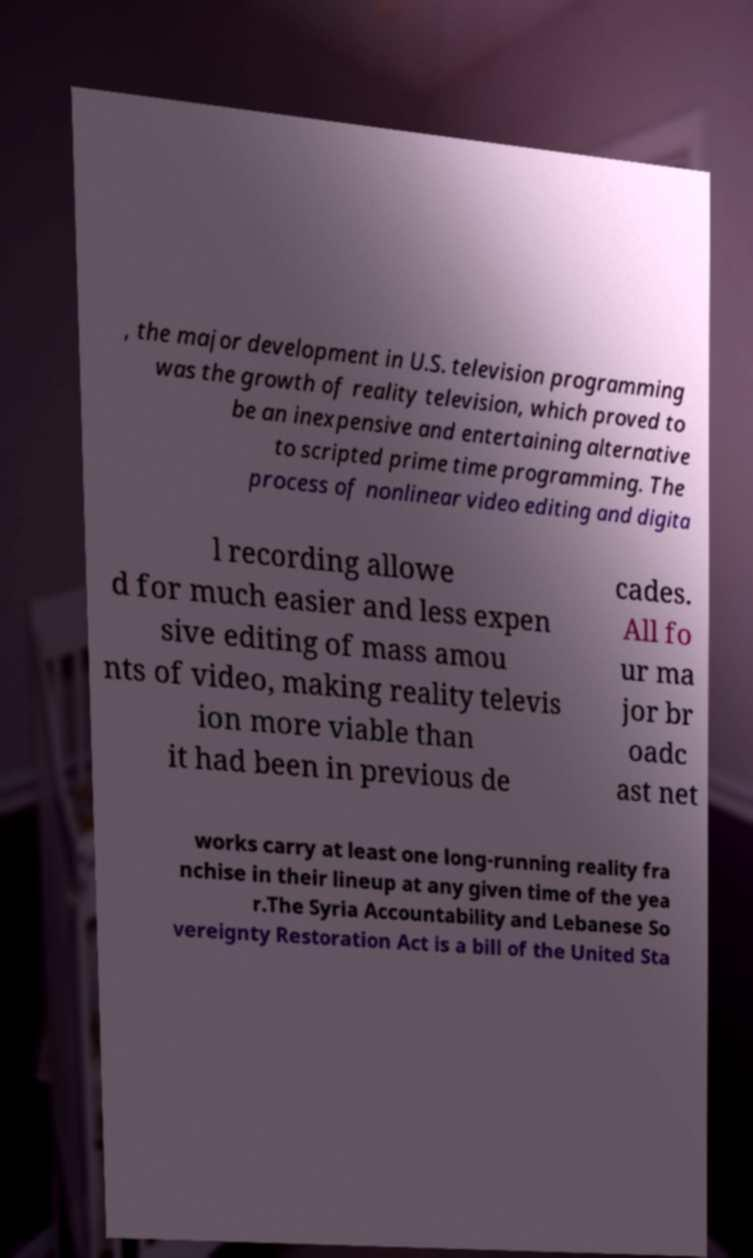Can you accurately transcribe the text from the provided image for me? , the major development in U.S. television programming was the growth of reality television, which proved to be an inexpensive and entertaining alternative to scripted prime time programming. The process of nonlinear video editing and digita l recording allowe d for much easier and less expen sive editing of mass amou nts of video, making reality televis ion more viable than it had been in previous de cades. All fo ur ma jor br oadc ast net works carry at least one long-running reality fra nchise in their lineup at any given time of the yea r.The Syria Accountability and Lebanese So vereignty Restoration Act is a bill of the United Sta 